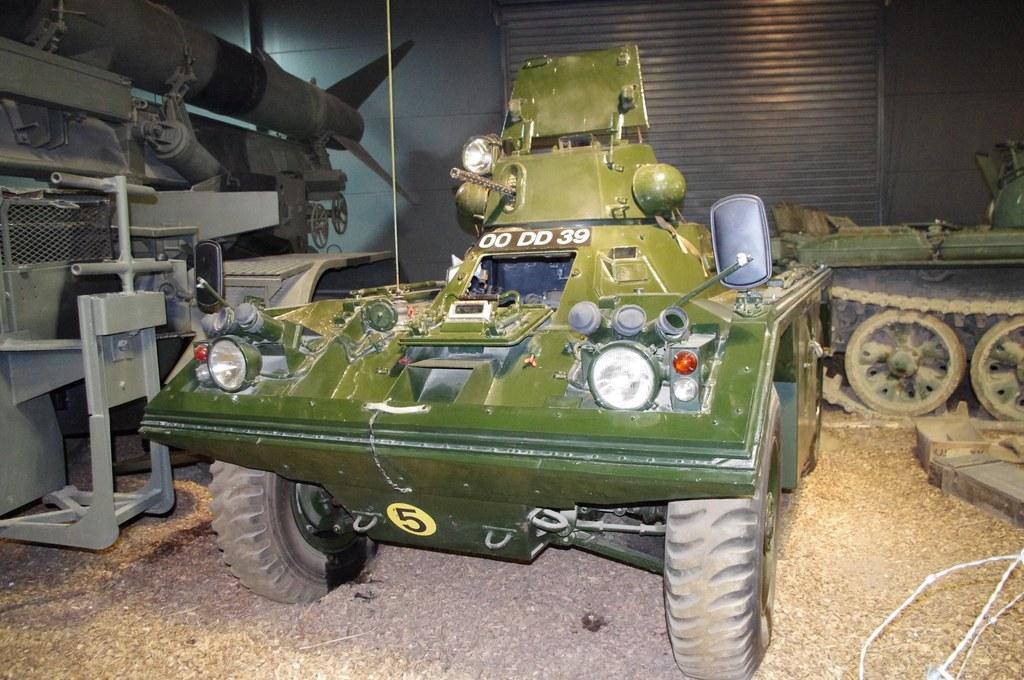Can you describe this image briefly? In this picture we can see a vehicle on the ground and in the background we can see a shutter, wall, wheels. 